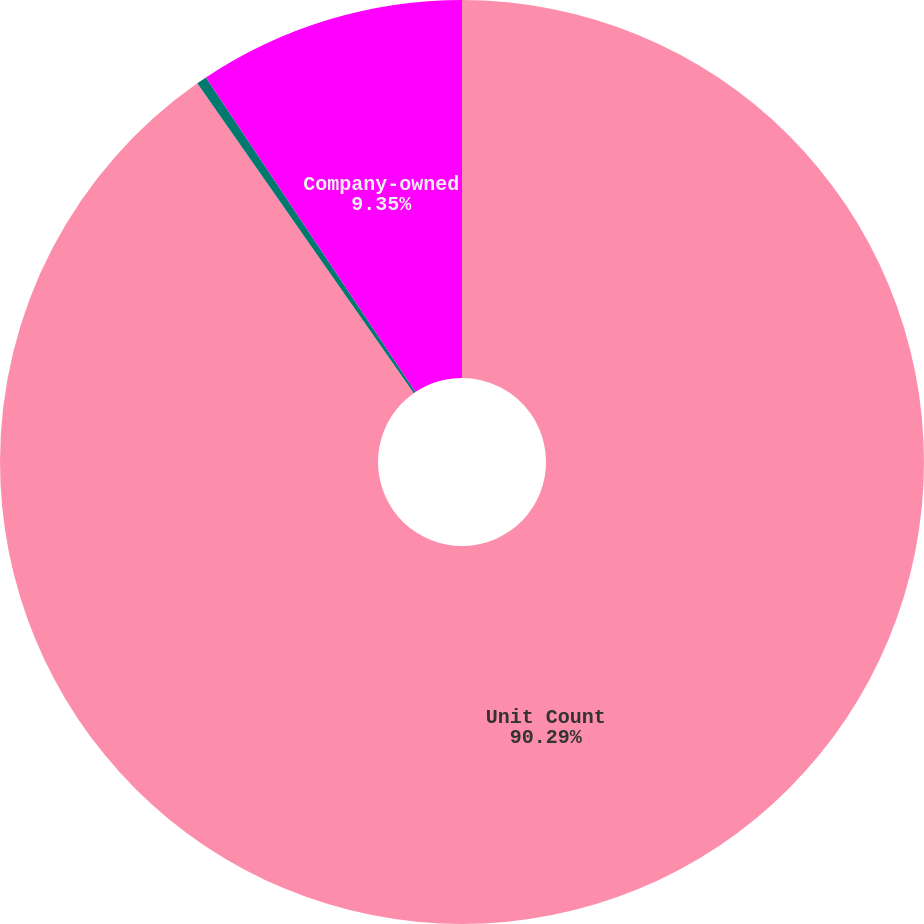<chart> <loc_0><loc_0><loc_500><loc_500><pie_chart><fcel>Unit Count<fcel>Franchise<fcel>Company-owned<nl><fcel>90.29%<fcel>0.36%<fcel>9.35%<nl></chart> 